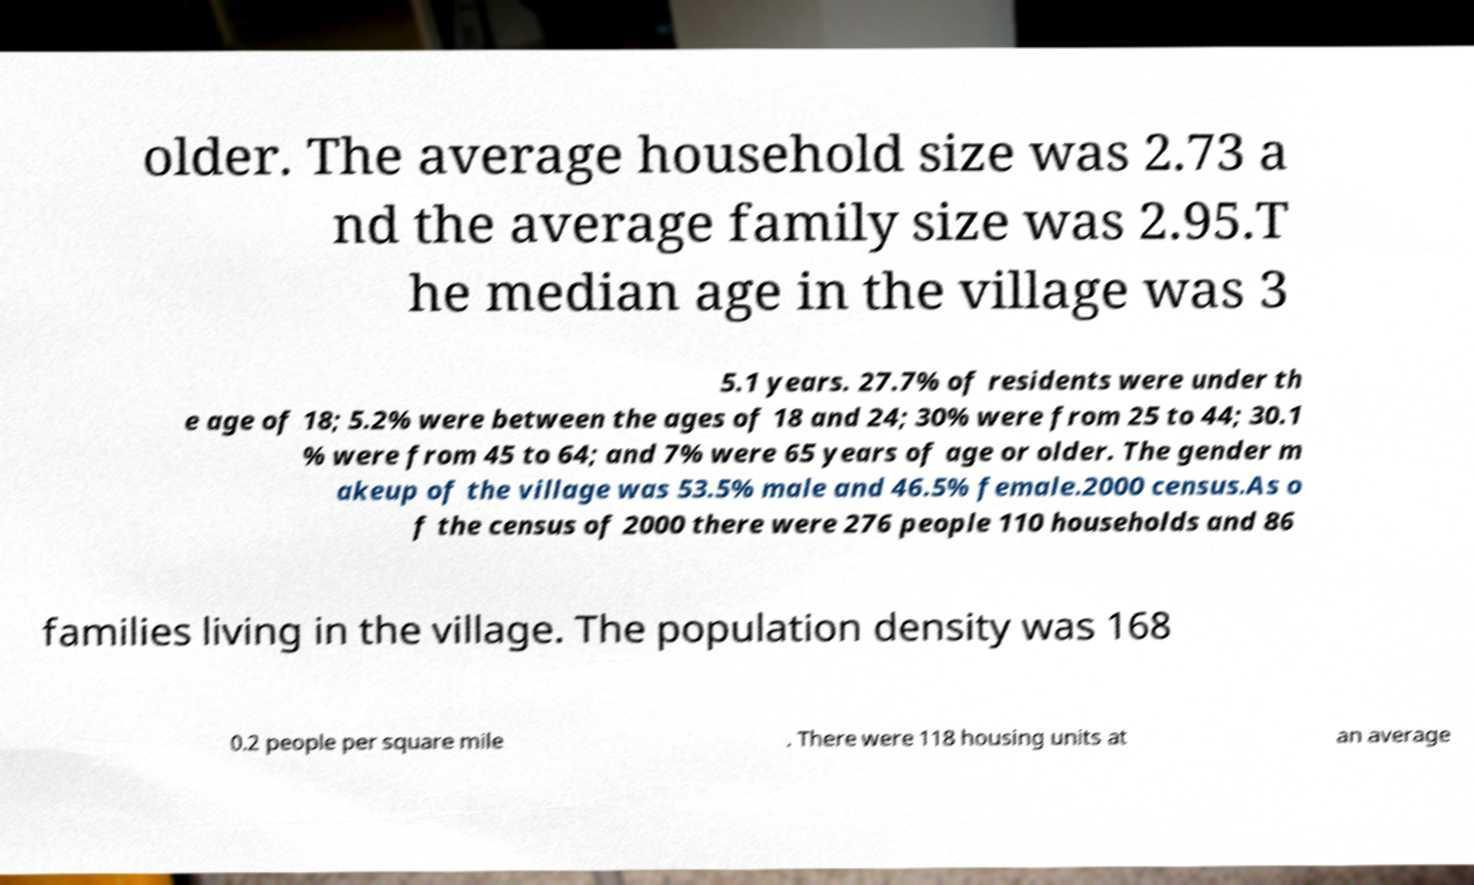Could you assist in decoding the text presented in this image and type it out clearly? older. The average household size was 2.73 a nd the average family size was 2.95.T he median age in the village was 3 5.1 years. 27.7% of residents were under th e age of 18; 5.2% were between the ages of 18 and 24; 30% were from 25 to 44; 30.1 % were from 45 to 64; and 7% were 65 years of age or older. The gender m akeup of the village was 53.5% male and 46.5% female.2000 census.As o f the census of 2000 there were 276 people 110 households and 86 families living in the village. The population density was 168 0.2 people per square mile . There were 118 housing units at an average 